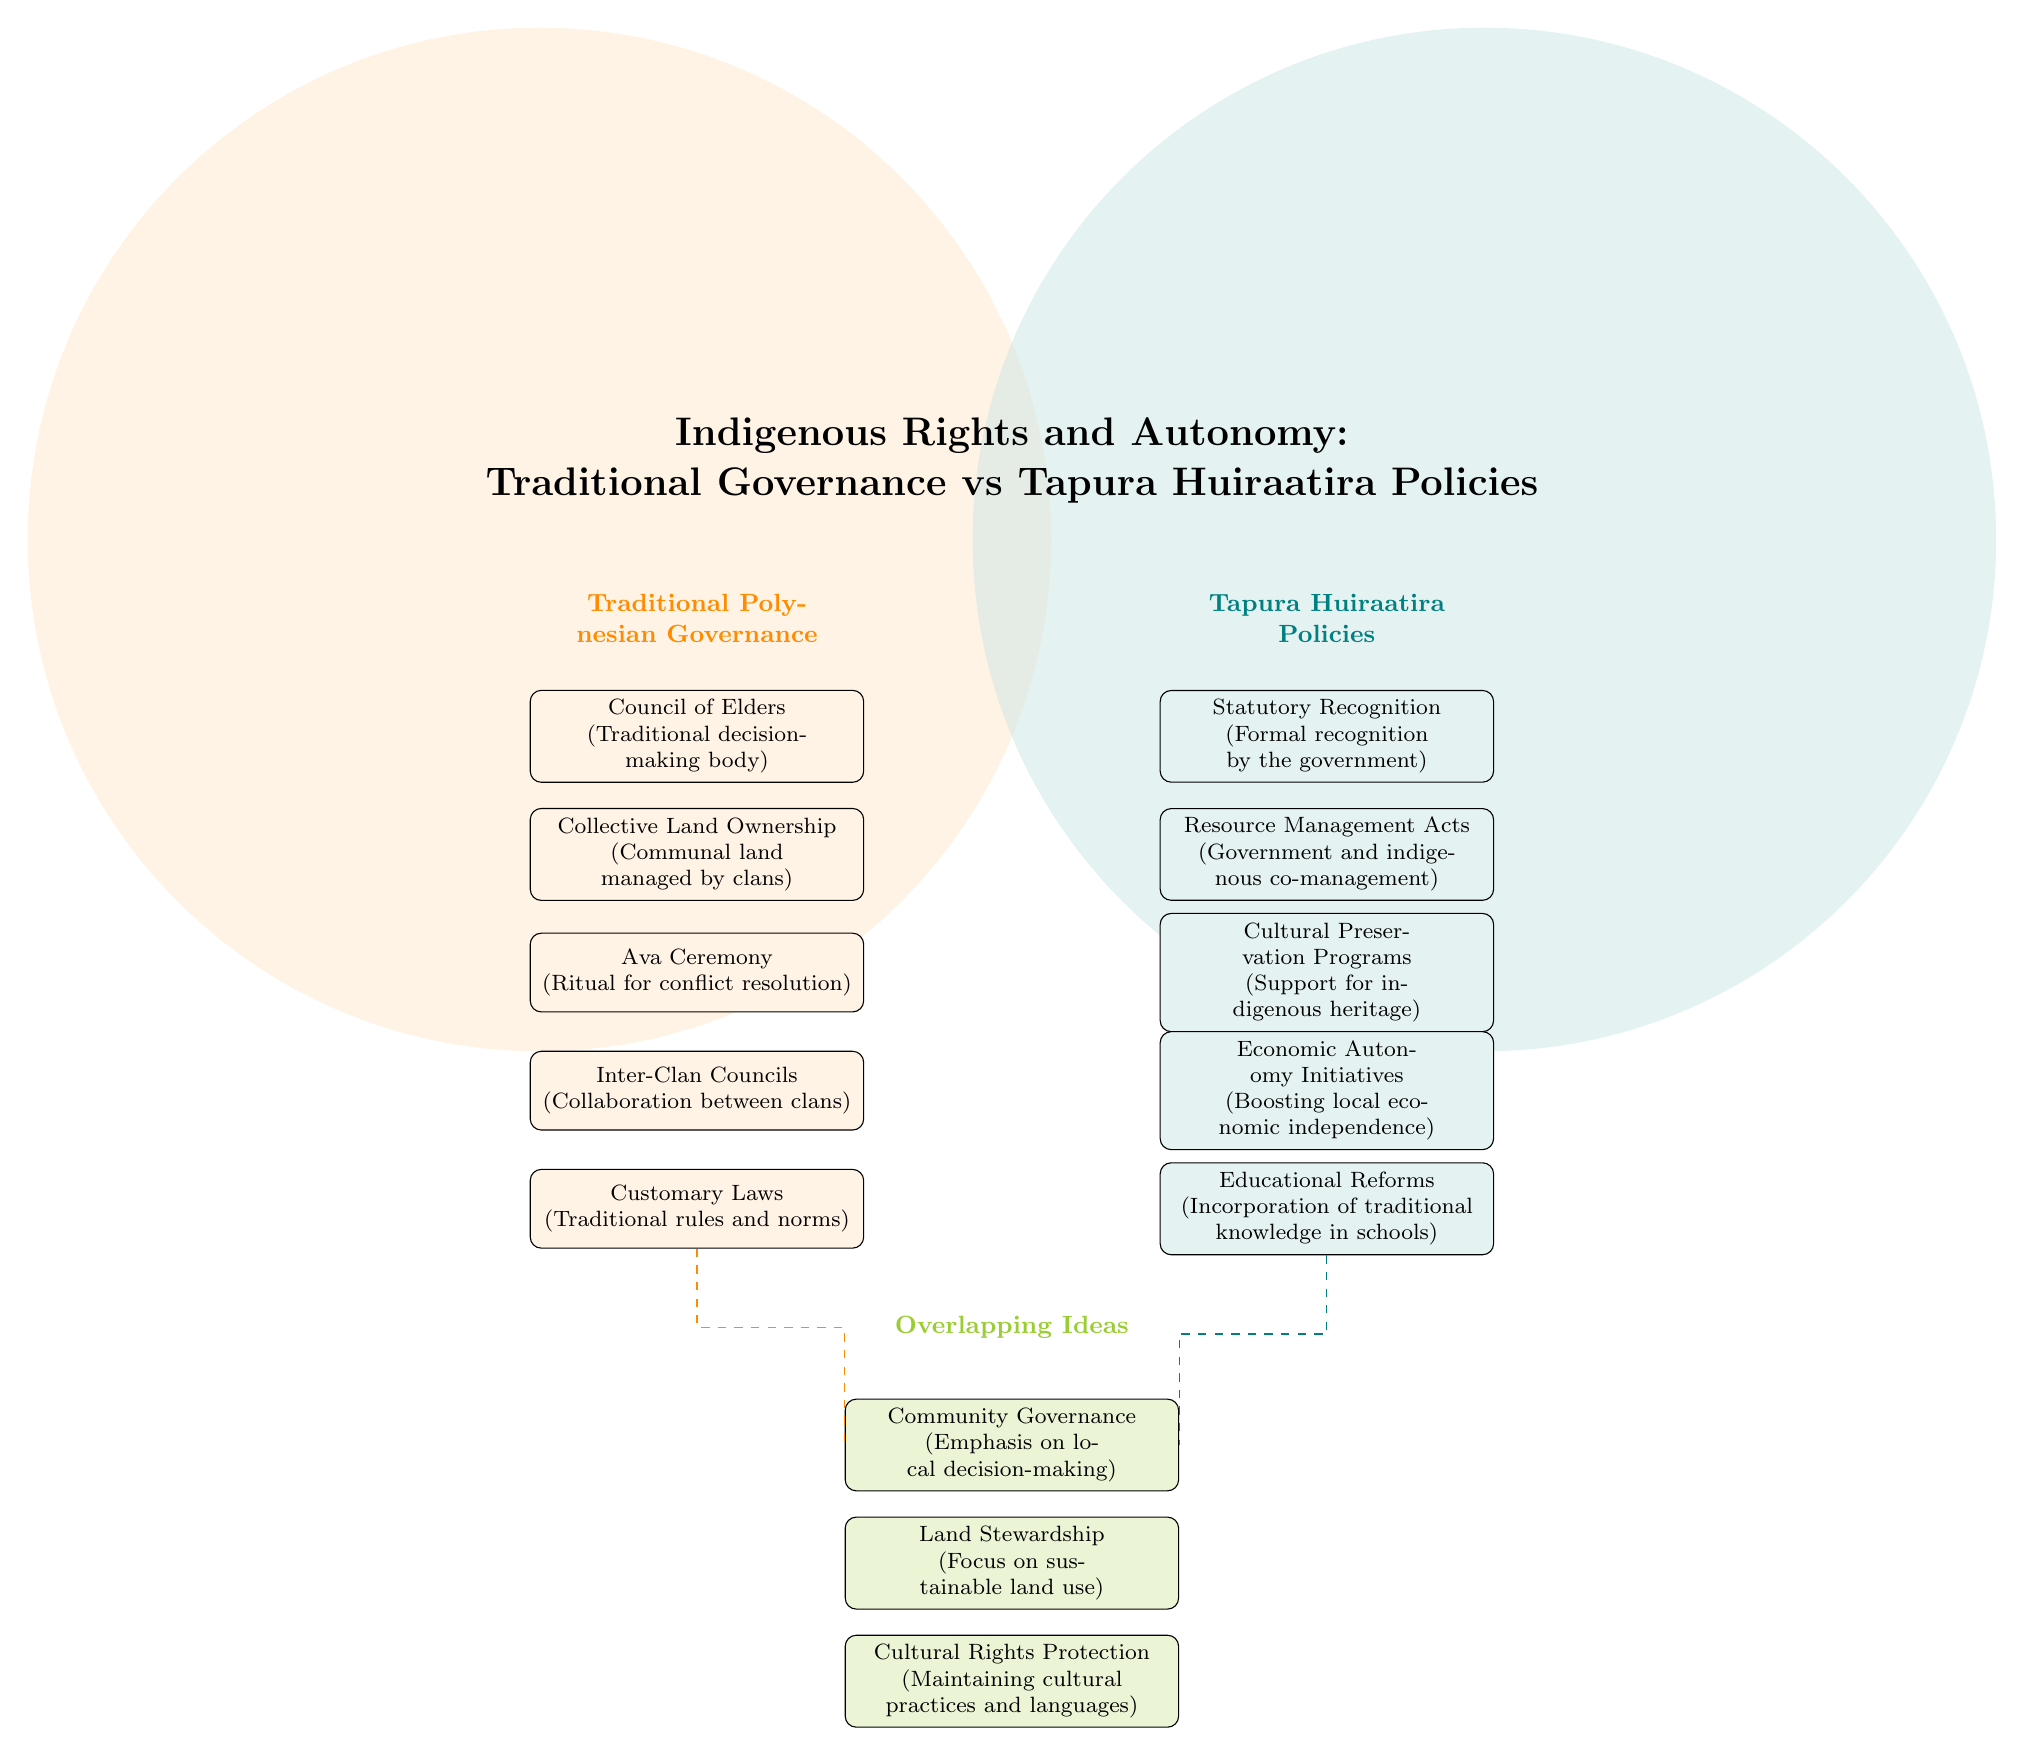What are the elements listed under Traditional Polynesian Governance? The diagram shows five elements listed under Traditional Polynesian Governance: Council of Elders, Collective Land Ownership, Ava Ceremony, Inter-Clan Councils, and Customary Laws. Each element is represented in the corresponding node.
Answer: Council of Elders, Collective Land Ownership, Ava Ceremony, Inter-Clan Councils, Customary Laws What overlaps exist between Traditional Polynesian Governance and Tapura Huiraatira Policies? The diagram identifies three overlapping ideas in the center: Community Governance, Land Stewardship, and Cultural Rights Protection. These ideas represent shared themes between the two systems of governance.
Answer: Community Governance, Land Stewardship, Cultural Rights Protection How many elements are listed under Tapura Huiraatira Policies? There are five elements shown under Tapura Huiraatira Policies: Statutory Recognition, Resource Management Acts, Cultural Preservation Programs, Economic Autonomy Initiatives, and Educational Reforms. Counting these nodes gives the total.
Answer: 5 Which element from Tapura Huiraatira relates to local economic independence? The relevant element from Tapura Huiraatira is Economic Autonomy Initiatives, which focuses on boosting local economic independence as part of its policy. This is directly stated in the node description.
Answer: Economic Autonomy Initiatives Identify a specific node that emphasizes local decision-making in governance. The node that emphasizes local decision-making in governance is Community Governance, which appears in the overlapping section of the diagram and is defined as focusing on local decision-making processes.
Answer: Community Governance How does Customary Laws relate to the overlapping ideas? Customary Laws from Traditional Polynesian Governance relates to Cultural Rights Protection in the overlap, as they represent traditional rules that help maintain cultural practices and languages. Both concepts aim to preserve cultural identity.
Answer: Cultural Rights Protection What is the focus of the node listed under Resource Management Acts? The focus of the Resource Management Acts is on government and indigenous co-management, as described in the node associated with Tapura Huiraatira Policies. This indicates a collaborative approach to resource management.
Answer: Government and indigenous co-management Which two nodes are connected by dashed lines indicating a relationship? The two nodes connected by dashed lines are Customary Laws (from Traditional Polynesian Governance) and Educational Reforms (from Tapura Huiraatira Policies), indicating a relationship focusing on cultural education and rights.
Answer: Customary Laws and Educational Reforms What unique governance aspect is highlighted in the Traditional Polynesian Governance section? The unique aspect highlighted in the Traditional Polynesian Governance section is the Council of Elders, which is a traditional decision-making body that plays a crucial role in governance through collective wisdom and experience.
Answer: Council of Elders 